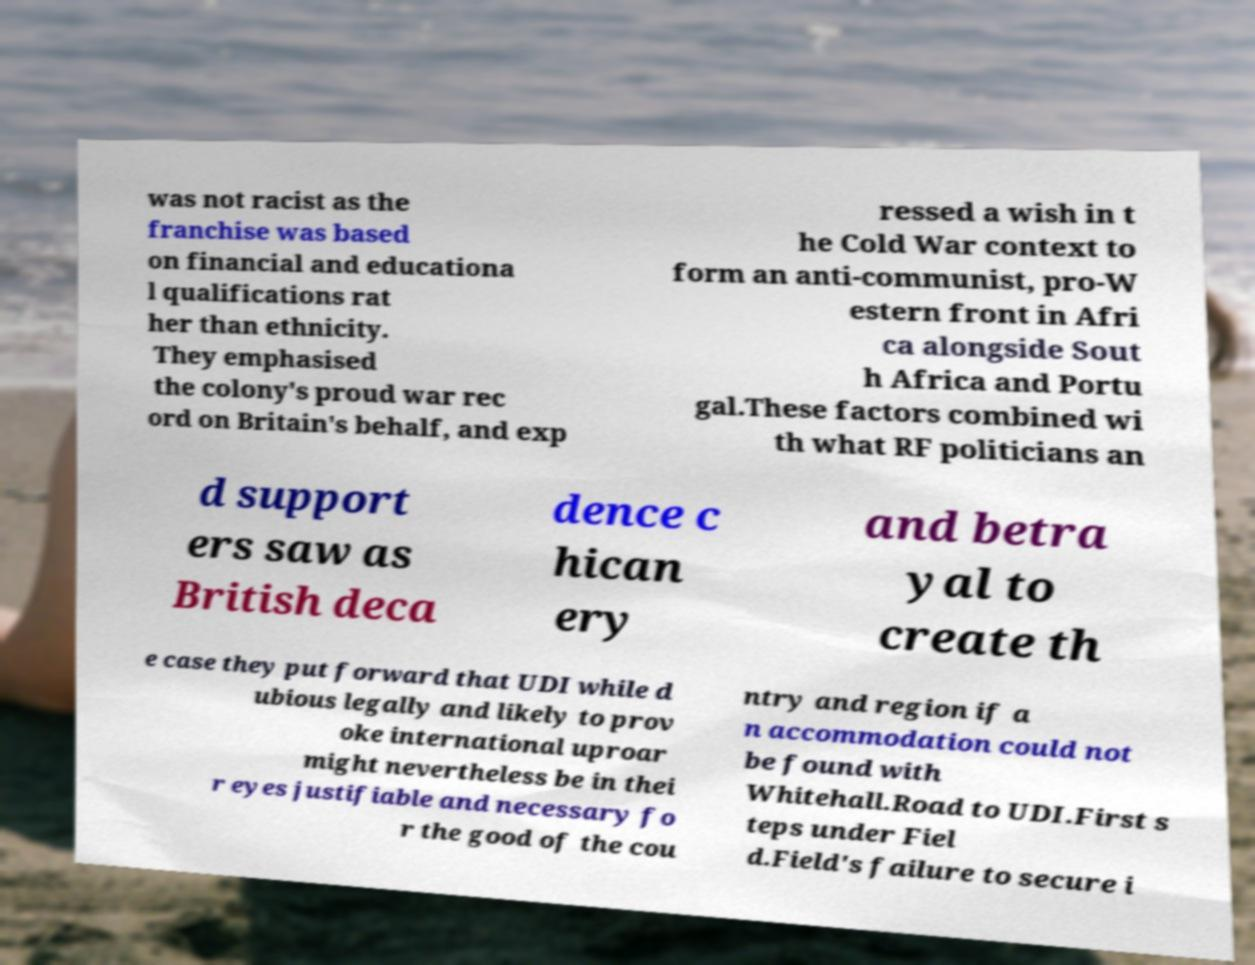What messages or text are displayed in this image? I need them in a readable, typed format. was not racist as the franchise was based on financial and educationa l qualifications rat her than ethnicity. They emphasised the colony's proud war rec ord on Britain's behalf, and exp ressed a wish in t he Cold War context to form an anti-communist, pro-W estern front in Afri ca alongside Sout h Africa and Portu gal.These factors combined wi th what RF politicians an d support ers saw as British deca dence c hican ery and betra yal to create th e case they put forward that UDI while d ubious legally and likely to prov oke international uproar might nevertheless be in thei r eyes justifiable and necessary fo r the good of the cou ntry and region if a n accommodation could not be found with Whitehall.Road to UDI.First s teps under Fiel d.Field's failure to secure i 